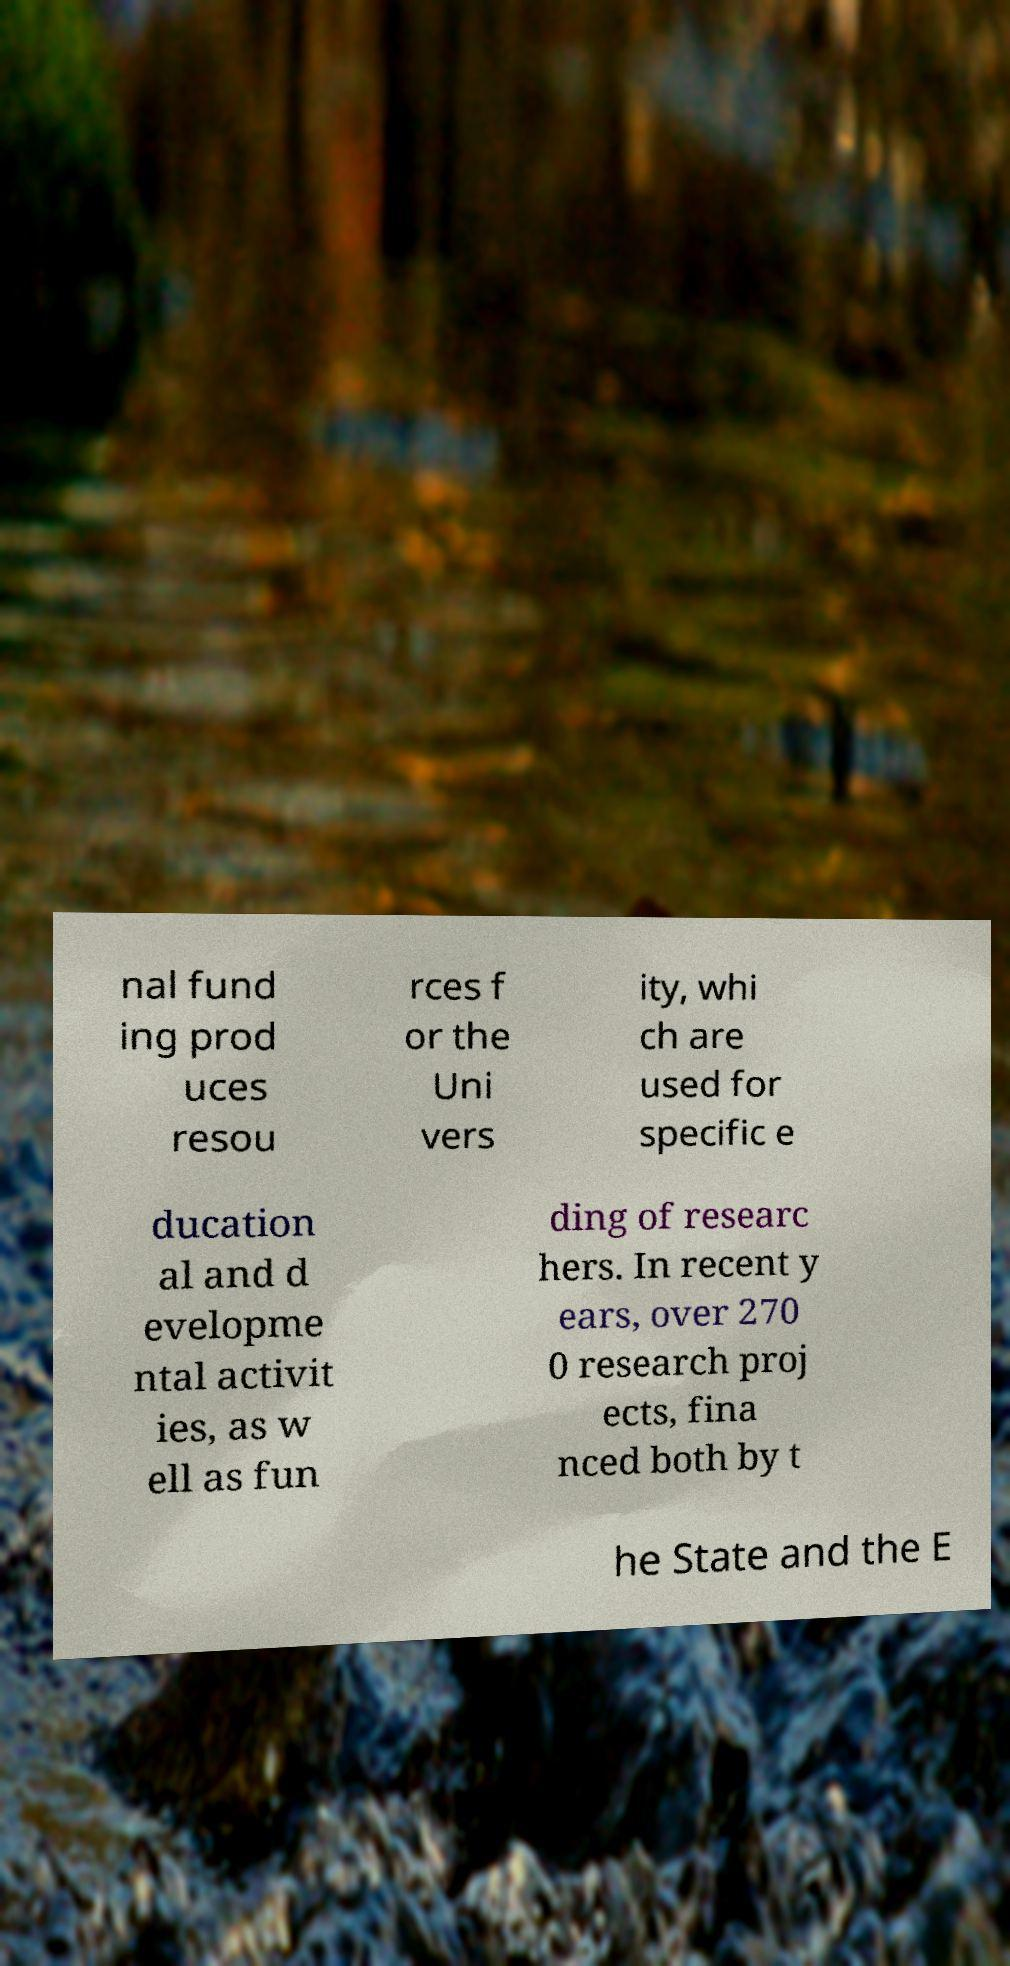Please read and relay the text visible in this image. What does it say? nal fund ing prod uces resou rces f or the Uni vers ity, whi ch are used for specific e ducation al and d evelopme ntal activit ies, as w ell as fun ding of researc hers. In recent y ears, over 270 0 research proj ects, fina nced both by t he State and the E 